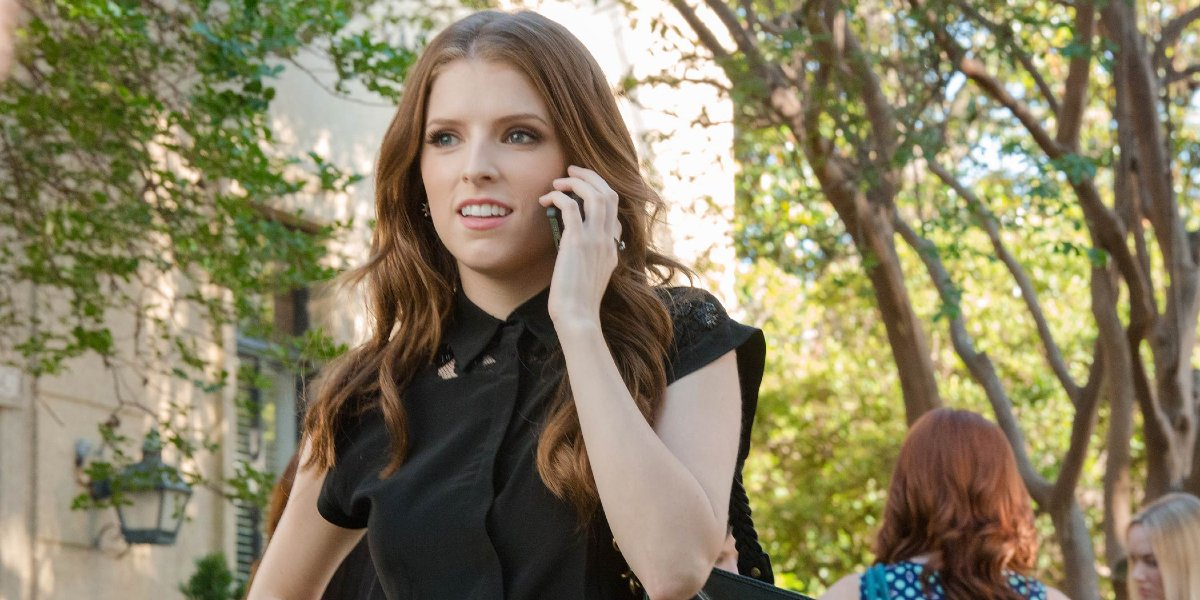What can we understand about her surroundings? The image shows the woman in an urban setting with a street lined with trees. It appears to be a peaceful area, possibly a residential neighborhood or a calm city street away from the hustle and bustle. 